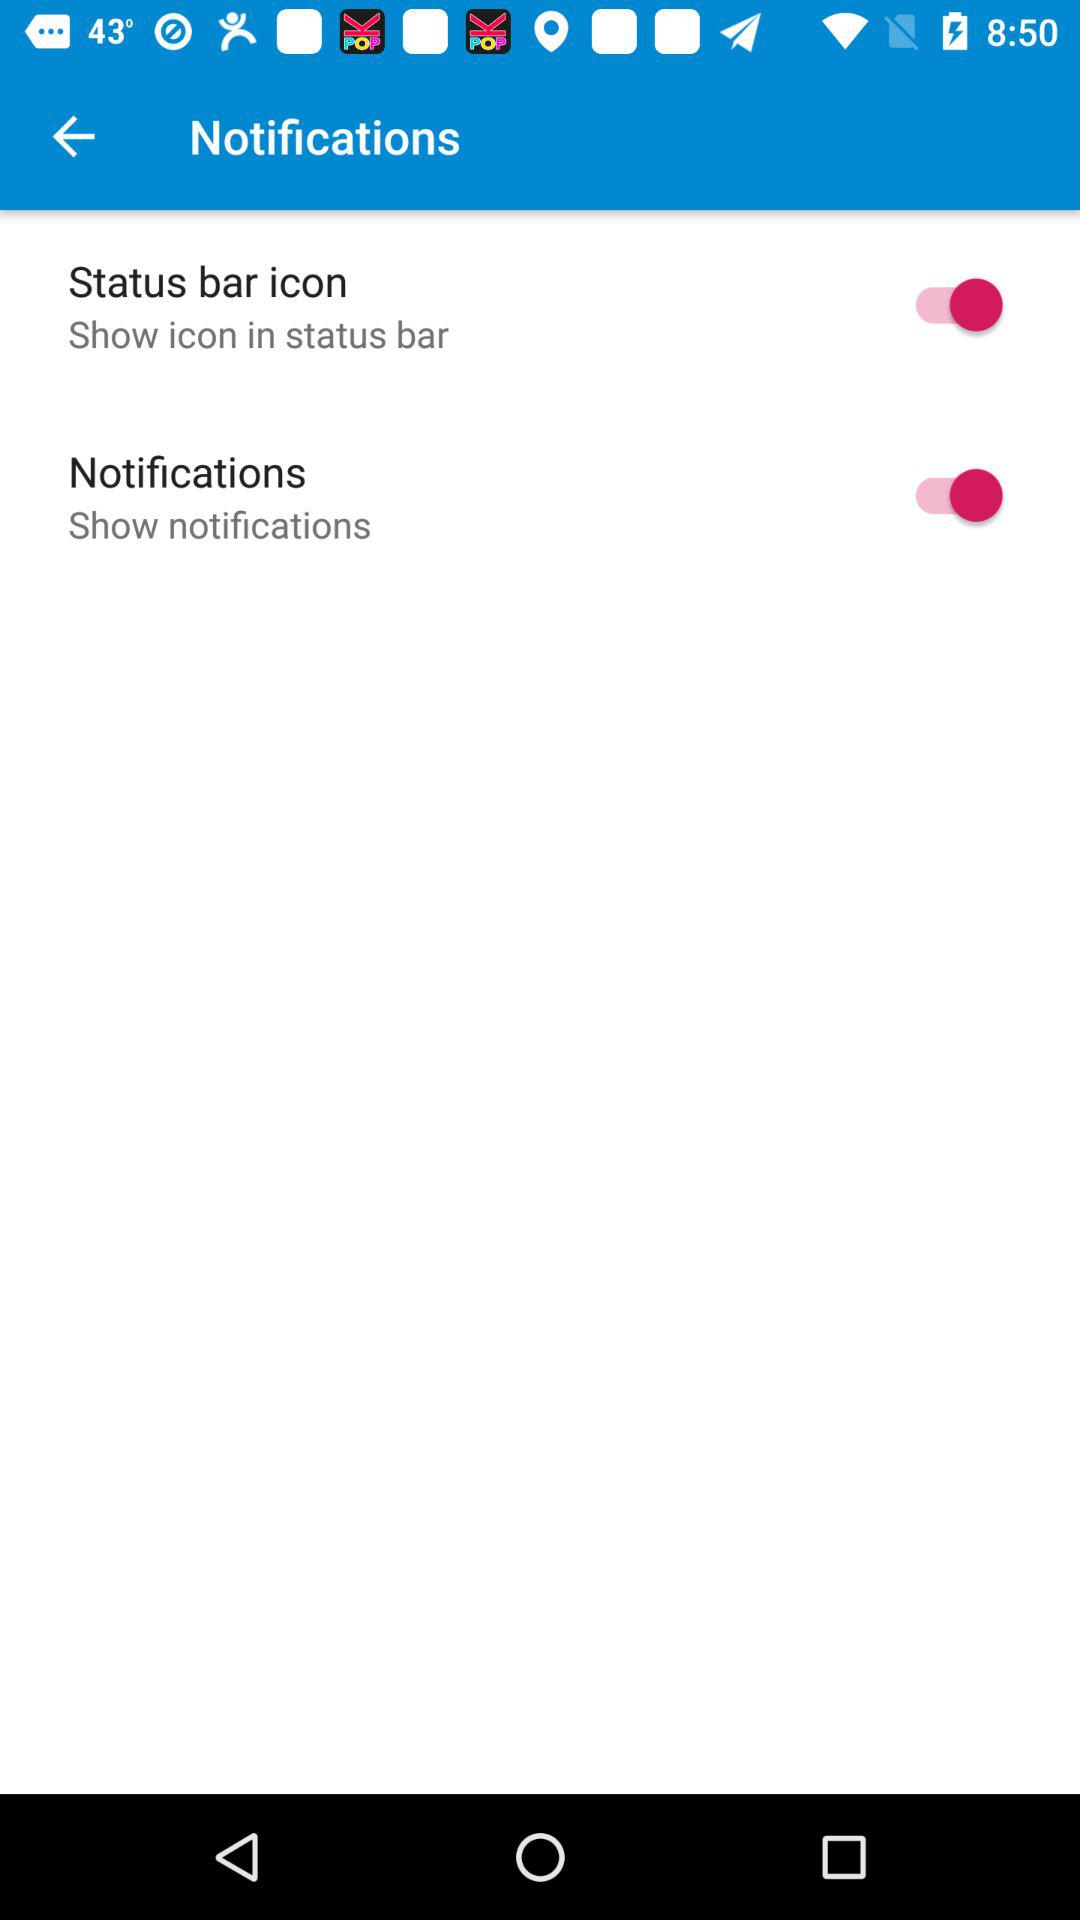What is the status of "Notifications"? The status of "Notifications" is "on". 